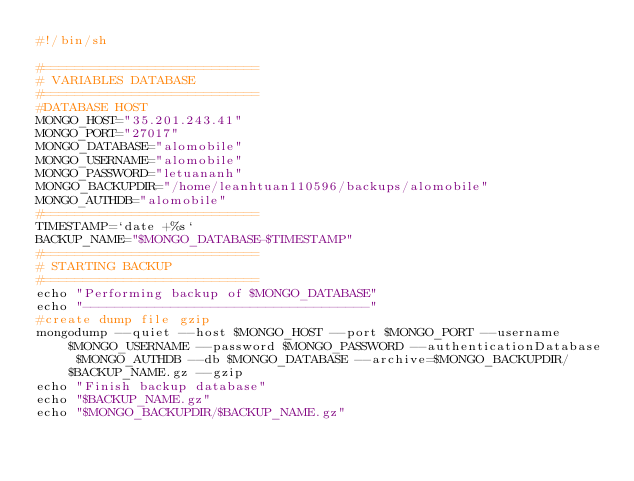<code> <loc_0><loc_0><loc_500><loc_500><_Bash_>#!/bin/sh

#===========================
# VARIABLES DATABASE
#===========================
#DATABASE HOST
MONGO_HOST="35.201.243.41"
MONGO_PORT="27017"
MONGO_DATABASE="alomobile"
MONGO_USERNAME="alomobile"
MONGO_PASSWORD="letuananh"
MONGO_BACKUPDIR="/home/leanhtuan110596/backups/alomobile"
MONGO_AUTHDB="alomobile"
#===========================
TIMESTAMP=`date +%s`
BACKUP_NAME="$MONGO_DATABASE-$TIMESTAMP"
#===========================
# STARTING BACKUP
#===========================
echo "Performing backup of $MONGO_DATABASE"
echo "------------------------------------"
#create dump file gzip
mongodump --quiet --host $MONGO_HOST --port $MONGO_PORT --username $MONGO_USERNAME --password $MONGO_PASSWORD --authenticationDatabase $MONGO_AUTHDB --db $MONGO_DATABASE --archive=$MONGO_BACKUPDIR/$BACKUP_NAME.gz --gzip
echo "Finish backup database"
echo "$BACKUP_NAME.gz"
echo "$MONGO_BACKUPDIR/$BACKUP_NAME.gz"
</code> 